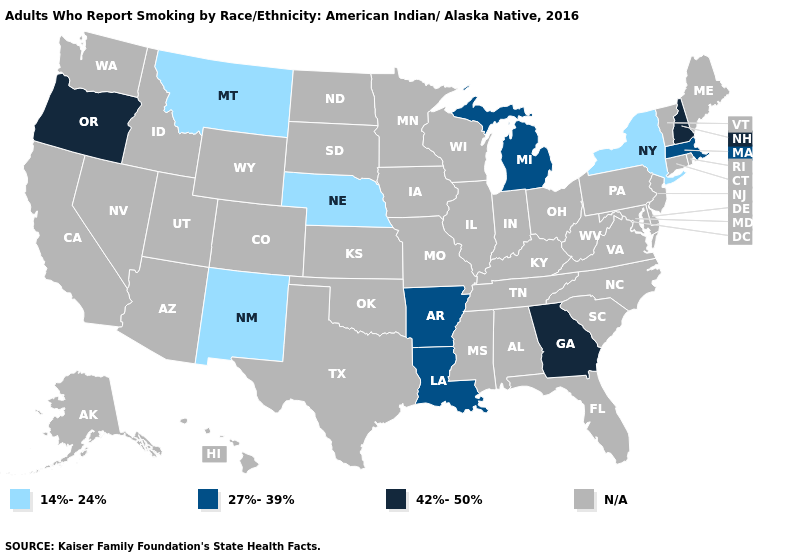What is the value of New York?
Keep it brief. 14%-24%. What is the value of New York?
Write a very short answer. 14%-24%. What is the value of Arizona?
Quick response, please. N/A. Does New Mexico have the lowest value in the West?
Quick response, please. Yes. Among the states that border Arizona , which have the lowest value?
Give a very brief answer. New Mexico. What is the lowest value in the West?
Give a very brief answer. 14%-24%. What is the lowest value in states that border Colorado?
Short answer required. 14%-24%. What is the lowest value in the USA?
Be succinct. 14%-24%. Which states have the highest value in the USA?
Be succinct. Georgia, New Hampshire, Oregon. What is the highest value in the USA?
Write a very short answer. 42%-50%. Name the states that have a value in the range 42%-50%?
Concise answer only. Georgia, New Hampshire, Oregon. Name the states that have a value in the range N/A?
Keep it brief. Alabama, Alaska, Arizona, California, Colorado, Connecticut, Delaware, Florida, Hawaii, Idaho, Illinois, Indiana, Iowa, Kansas, Kentucky, Maine, Maryland, Minnesota, Mississippi, Missouri, Nevada, New Jersey, North Carolina, North Dakota, Ohio, Oklahoma, Pennsylvania, Rhode Island, South Carolina, South Dakota, Tennessee, Texas, Utah, Vermont, Virginia, Washington, West Virginia, Wisconsin, Wyoming. Which states have the lowest value in the MidWest?
Give a very brief answer. Nebraska. What is the lowest value in the Northeast?
Answer briefly. 14%-24%. 